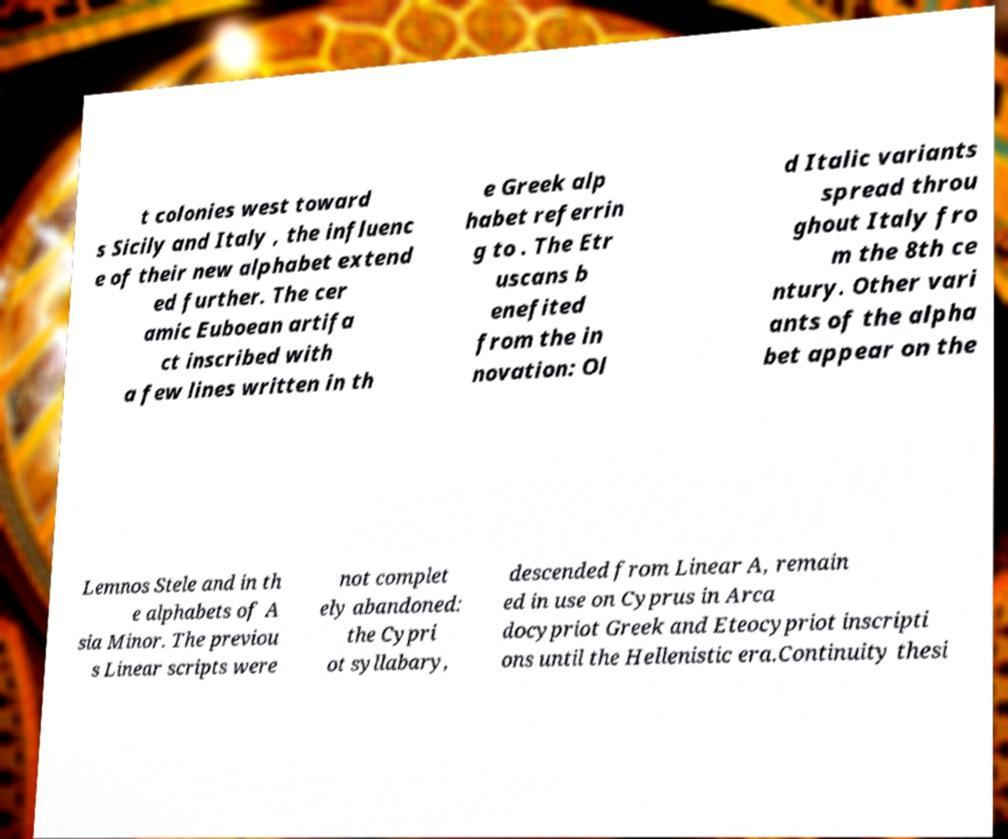Please read and relay the text visible in this image. What does it say? t colonies west toward s Sicily and Italy , the influenc e of their new alphabet extend ed further. The cer amic Euboean artifa ct inscribed with a few lines written in th e Greek alp habet referrin g to . The Etr uscans b enefited from the in novation: Ol d Italic variants spread throu ghout Italy fro m the 8th ce ntury. Other vari ants of the alpha bet appear on the Lemnos Stele and in th e alphabets of A sia Minor. The previou s Linear scripts were not complet ely abandoned: the Cypri ot syllabary, descended from Linear A, remain ed in use on Cyprus in Arca docypriot Greek and Eteocypriot inscripti ons until the Hellenistic era.Continuity thesi 